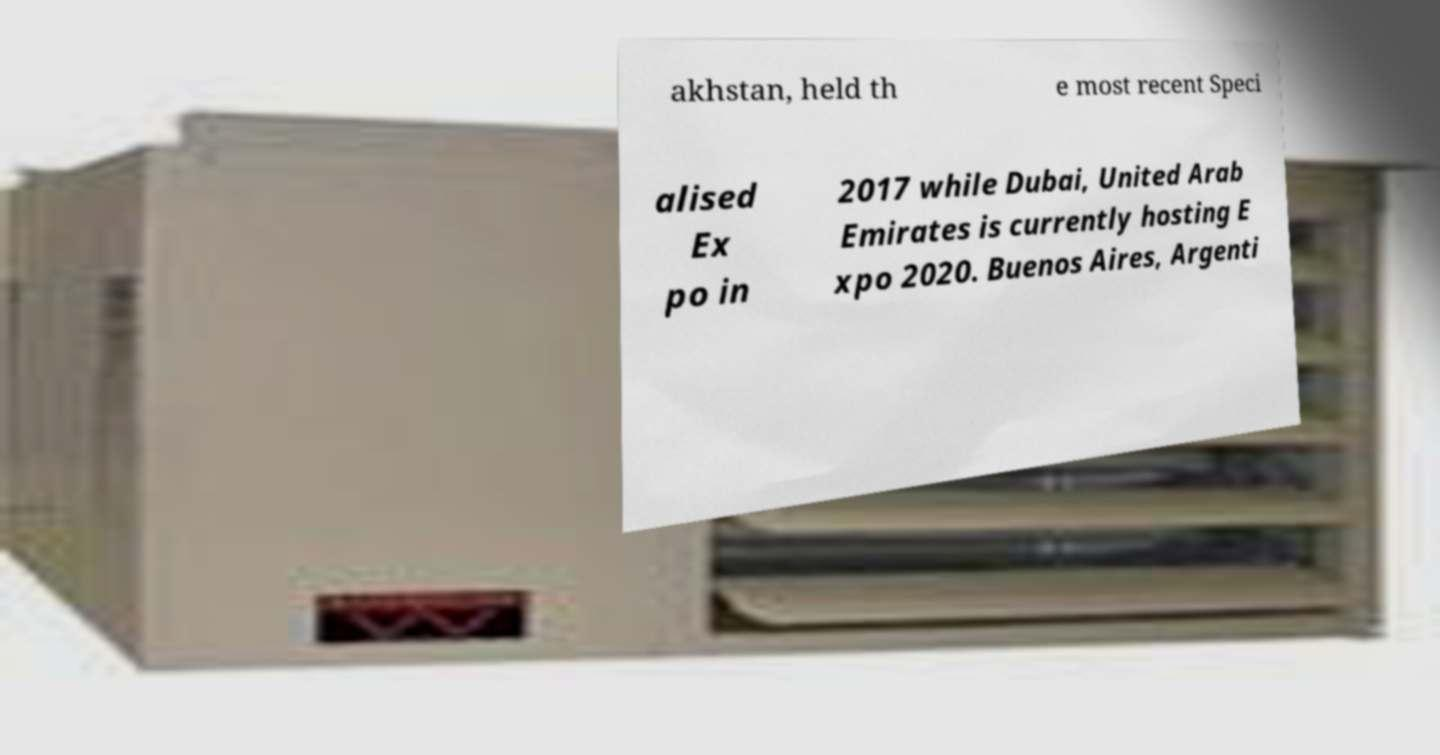Could you extract and type out the text from this image? akhstan, held th e most recent Speci alised Ex po in 2017 while Dubai, United Arab Emirates is currently hosting E xpo 2020. Buenos Aires, Argenti 